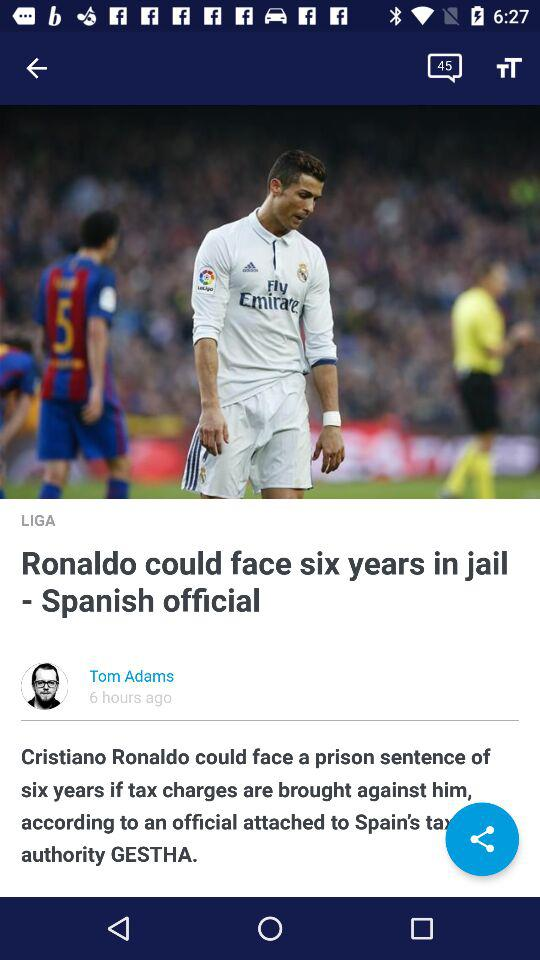How many hours ago was the article posted? The article was posted 6 hours ago. 